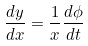Convert formula to latex. <formula><loc_0><loc_0><loc_500><loc_500>\frac { d y } { d x } = \frac { 1 } { x } \frac { d \phi } { d t }</formula> 